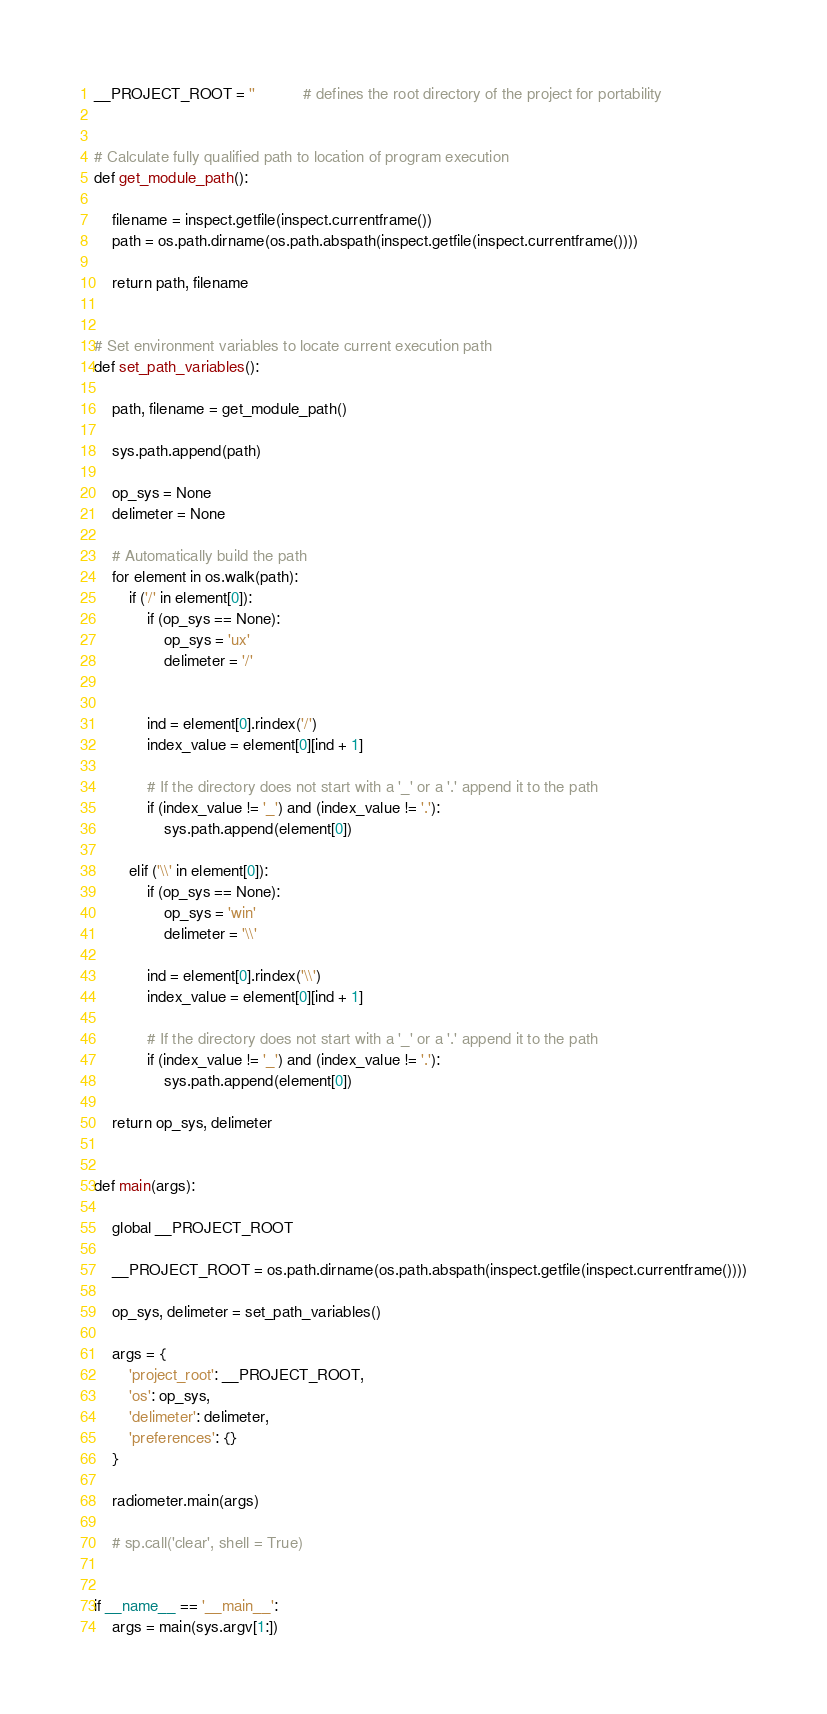<code> <loc_0><loc_0><loc_500><loc_500><_Python_>__PROJECT_ROOT = ''           # defines the root directory of the project for portability


# Calculate fully qualified path to location of program execution
def get_module_path():

    filename = inspect.getfile(inspect.currentframe())
    path = os.path.dirname(os.path.abspath(inspect.getfile(inspect.currentframe())))

    return path, filename


# Set environment variables to locate current execution path
def set_path_variables():

    path, filename = get_module_path()

    sys.path.append(path)

    op_sys = None
    delimeter = None

    # Automatically build the path
    for element in os.walk(path):
        if ('/' in element[0]):
            if (op_sys == None):
                op_sys = 'ux'
                delimeter = '/'


            ind = element[0].rindex('/')
            index_value = element[0][ind + 1]

            # If the directory does not start with a '_' or a '.' append it to the path
            if (index_value != '_') and (index_value != '.'):
                sys.path.append(element[0])

        elif ('\\' in element[0]):
            if (op_sys == None):
                op_sys = 'win'
                delimeter = '\\'

            ind = element[0].rindex('\\')
            index_value = element[0][ind + 1]

            # If the directory does not start with a '_' or a '.' append it to the path
            if (index_value != '_') and (index_value != '.'):
                sys.path.append(element[0])

    return op_sys, delimeter


def main(args):

    global __PROJECT_ROOT

    __PROJECT_ROOT = os.path.dirname(os.path.abspath(inspect.getfile(inspect.currentframe())))

    op_sys, delimeter = set_path_variables()

    args = {
        'project_root': __PROJECT_ROOT,
        'os': op_sys,
        'delimeter': delimeter,
        'preferences': {}
    }

    radiometer.main(args)

    # sp.call('clear', shell = True)


if __name__ == '__main__':
    args = main(sys.argv[1:])
</code> 